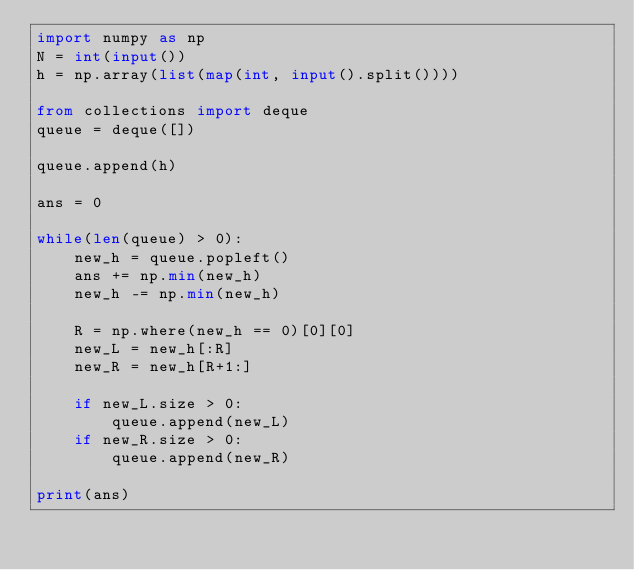Convert code to text. <code><loc_0><loc_0><loc_500><loc_500><_Python_>import numpy as np
N = int(input())
h = np.array(list(map(int, input().split())))

from collections import deque
queue = deque([])

queue.append(h)

ans = 0

while(len(queue) > 0):
    new_h = queue.popleft()
    ans += np.min(new_h)
    new_h -= np.min(new_h)
    
    R = np.where(new_h == 0)[0][0]
    new_L = new_h[:R]
    new_R = new_h[R+1:]
    
    if new_L.size > 0:
        queue.append(new_L)
    if new_R.size > 0:
        queue.append(new_R)
    
print(ans)</code> 